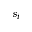Convert formula to latex. <formula><loc_0><loc_0><loc_500><loc_500>s _ { i }</formula> 